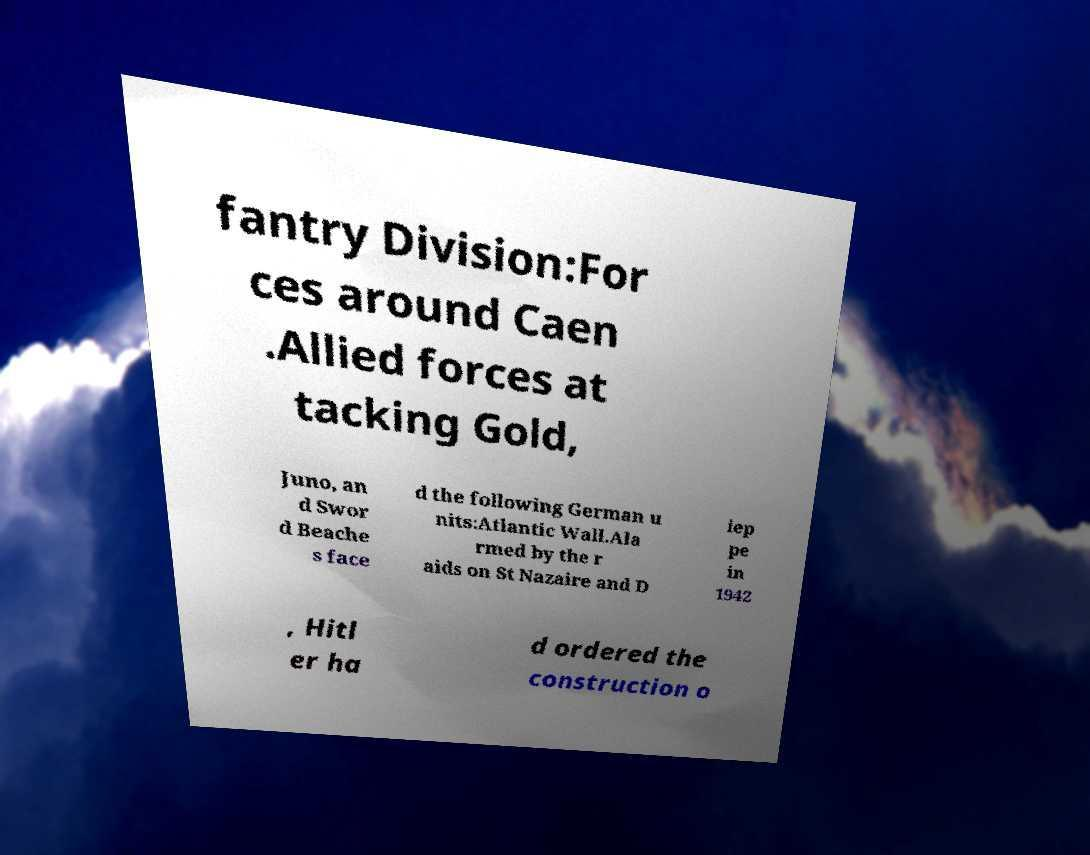Could you assist in decoding the text presented in this image and type it out clearly? fantry Division:For ces around Caen .Allied forces at tacking Gold, Juno, an d Swor d Beache s face d the following German u nits:Atlantic Wall.Ala rmed by the r aids on St Nazaire and D iep pe in 1942 , Hitl er ha d ordered the construction o 